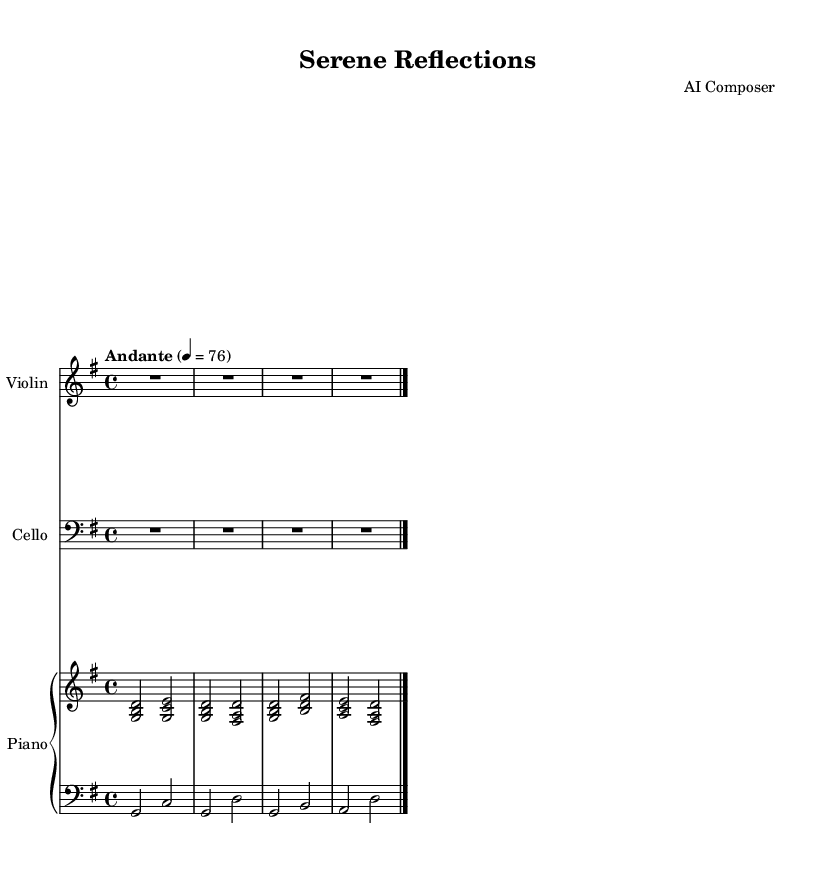What is the key signature of this music? The key signature is G major, which has one sharp (F#). This can be determined by identifying the note after the clef in the first measure where the F# is indicated.
Answer: G major What is the time signature of this composition? The time signature is 4/4, as shown at the beginning of the sheet music. It visually indicates that there are four beats in each measure and the quarter note gets one beat.
Answer: 4/4 What is the tempo marking of this piece? The tempo marking is "Andante," which suggests a moderate pace of walking speed. This can be seen in the tempo indication written above the staff.
Answer: Andante How many measures are there in the piece? There are 2 measures in total for each of the three instruments (piano, violin, and cello), and the music notation indicates the end with a double bar line after these measures.
Answer: 2 What instruments are featured in this composition? The composition features piano, violin, and cello, which are indicated in each of the respective staves at the beginning of the score.
Answer: Piano, Violin, Cello What is the primary rhythmic figure used in the piano part? The primary rhythmic figure in the piano part consists mainly of half notes and quarter notes, as evident in how the notes are arranged in each of the staves. Most measures feature this combination.
Answer: Half notes and quarter notes What is the starting note for the piano right hand? The starting note for the piano right hand is G, as indicated by the lowest note in the first measure of the right-hand staff.
Answer: G 